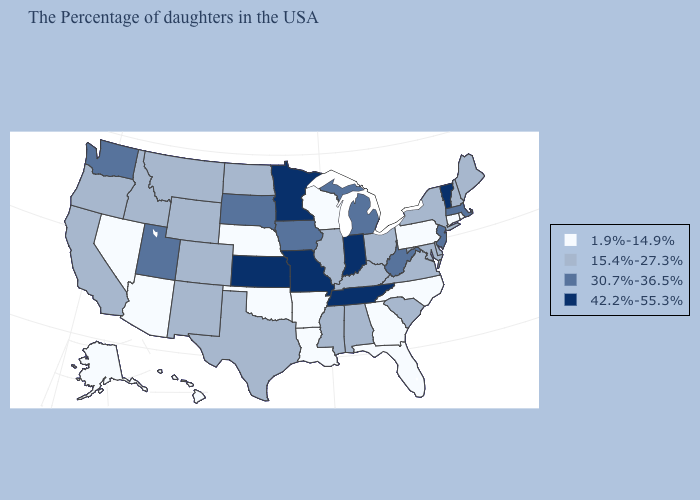Among the states that border North Dakota , does Minnesota have the highest value?
Answer briefly. Yes. Name the states that have a value in the range 1.9%-14.9%?
Write a very short answer. Rhode Island, Connecticut, Pennsylvania, North Carolina, Florida, Georgia, Wisconsin, Louisiana, Arkansas, Nebraska, Oklahoma, Arizona, Nevada, Alaska, Hawaii. Is the legend a continuous bar?
Be succinct. No. Does Rhode Island have the highest value in the Northeast?
Give a very brief answer. No. What is the lowest value in the MidWest?
Answer briefly. 1.9%-14.9%. Among the states that border Montana , which have the highest value?
Give a very brief answer. South Dakota. What is the value of West Virginia?
Concise answer only. 30.7%-36.5%. Name the states that have a value in the range 30.7%-36.5%?
Answer briefly. Massachusetts, New Jersey, West Virginia, Michigan, Iowa, South Dakota, Utah, Washington. What is the value of New Jersey?
Concise answer only. 30.7%-36.5%. Does the map have missing data?
Short answer required. No. Among the states that border Oregon , does California have the lowest value?
Write a very short answer. No. Name the states that have a value in the range 42.2%-55.3%?
Concise answer only. Vermont, Indiana, Tennessee, Missouri, Minnesota, Kansas. Among the states that border Montana , which have the lowest value?
Concise answer only. North Dakota, Wyoming, Idaho. Does Vermont have the highest value in the Northeast?
Short answer required. Yes. 